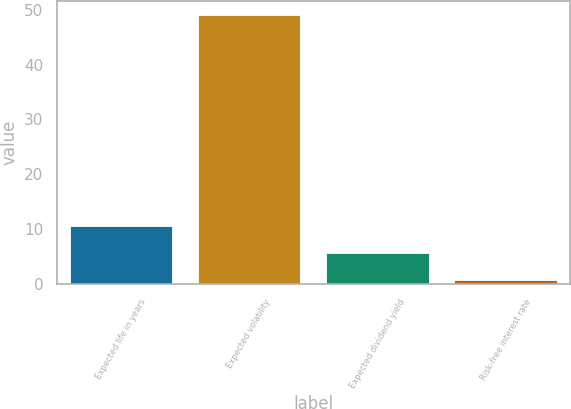Convert chart to OTSL. <chart><loc_0><loc_0><loc_500><loc_500><bar_chart><fcel>Expected life in years<fcel>Expected volatility<fcel>Expected dividend yield<fcel>Risk-free interest rate<nl><fcel>10.51<fcel>49.11<fcel>5.68<fcel>0.85<nl></chart> 